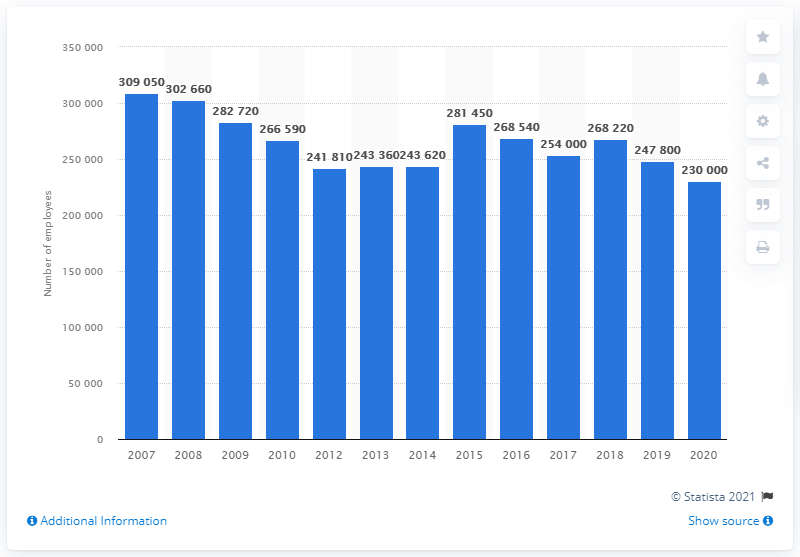Specify some key components in this picture. In the year 2020, AT&T had approximately 230,000 employees. In 2020, AT&T had approximately 230,000 employees. 